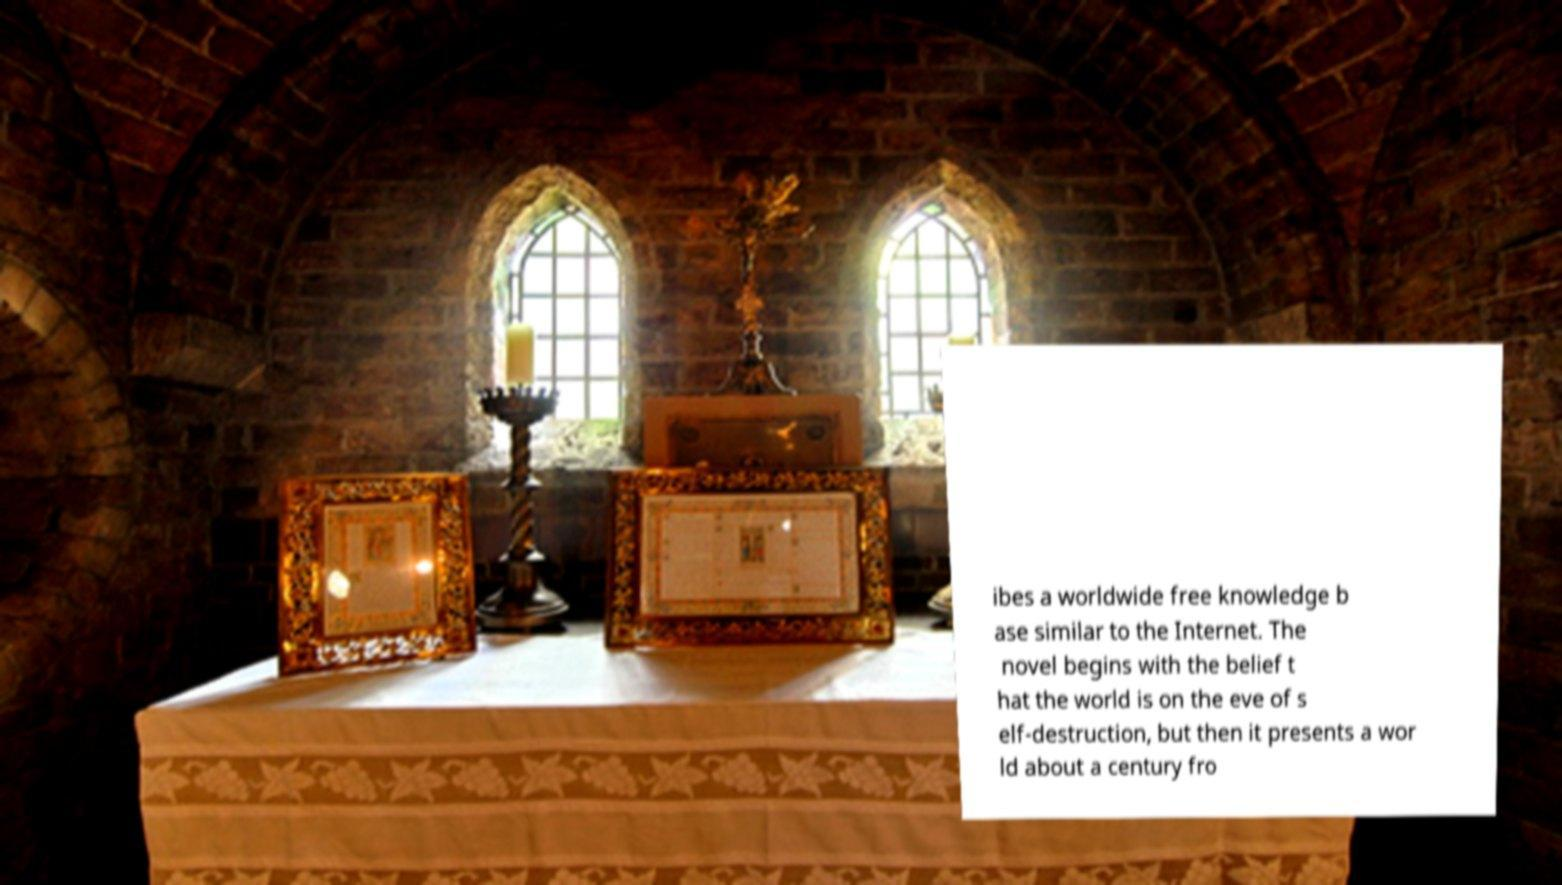Please identify and transcribe the text found in this image. ibes a worldwide free knowledge b ase similar to the Internet. The novel begins with the belief t hat the world is on the eve of s elf-destruction, but then it presents a wor ld about a century fro 